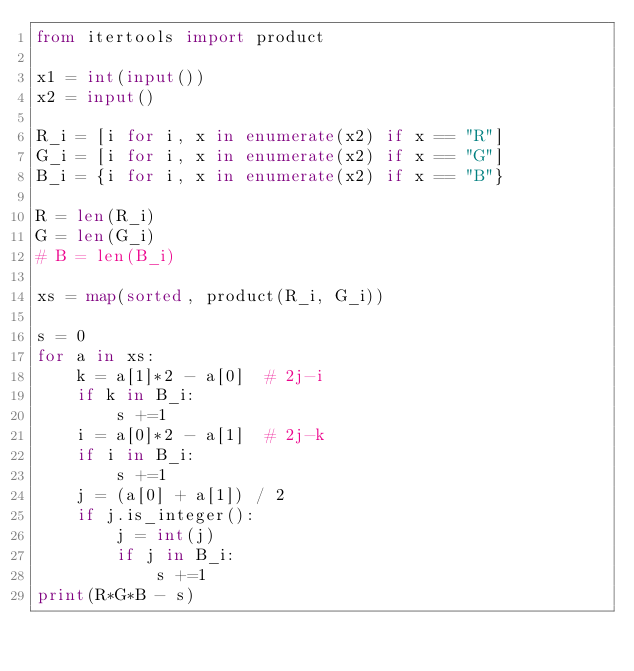<code> <loc_0><loc_0><loc_500><loc_500><_Python_>from itertools import product

x1 = int(input())
x2 = input()

R_i = [i for i, x in enumerate(x2) if x == "R"]
G_i = [i for i, x in enumerate(x2) if x == "G"]
B_i = {i for i, x in enumerate(x2) if x == "B"}

R = len(R_i)
G = len(G_i)
# B = len(B_i)

xs = map(sorted, product(R_i, G_i))

s = 0
for a in xs:
    k = a[1]*2 - a[0]  # 2j-i
    if k in B_i:
        s +=1
    i = a[0]*2 - a[1]  # 2j-k
    if i in B_i:
        s +=1
    j = (a[0] + a[1]) / 2
    if j.is_integer():
        j = int(j)
        if j in B_i:
            s +=1
print(R*G*B - s)</code> 